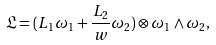Convert formula to latex. <formula><loc_0><loc_0><loc_500><loc_500>\mathfrak { L } = ( L _ { 1 } \omega _ { 1 } + \frac { L _ { 2 } } { w } \omega _ { 2 } ) \otimes \omega _ { 1 } \wedge \omega _ { 2 } ,</formula> 